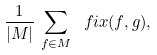<formula> <loc_0><loc_0><loc_500><loc_500>\frac { 1 } { | M | } \, \sum _ { f \in M } \ f i x ( f , g ) ,</formula> 